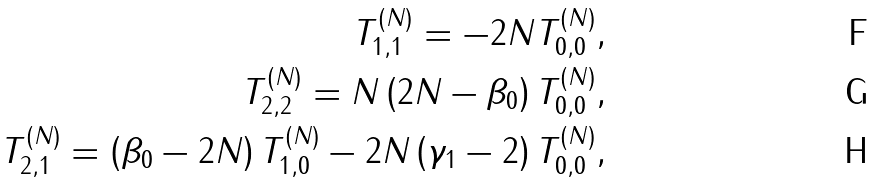Convert formula to latex. <formula><loc_0><loc_0><loc_500><loc_500>T _ { 1 , 1 } ^ { ( N ) } = - 2 N T _ { 0 , 0 } ^ { ( N ) } , \\ T _ { 2 , 2 } ^ { ( N ) } = N \left ( 2 N - \beta _ { 0 } \right ) T _ { 0 , 0 } ^ { ( N ) } , \\ T _ { 2 , 1 } ^ { ( N ) } = \left ( \beta _ { 0 } - 2 N \right ) T _ { 1 , 0 } ^ { ( N ) } - 2 N \left ( \gamma _ { 1 } - 2 \right ) T _ { 0 , 0 } ^ { ( N ) } ,</formula> 